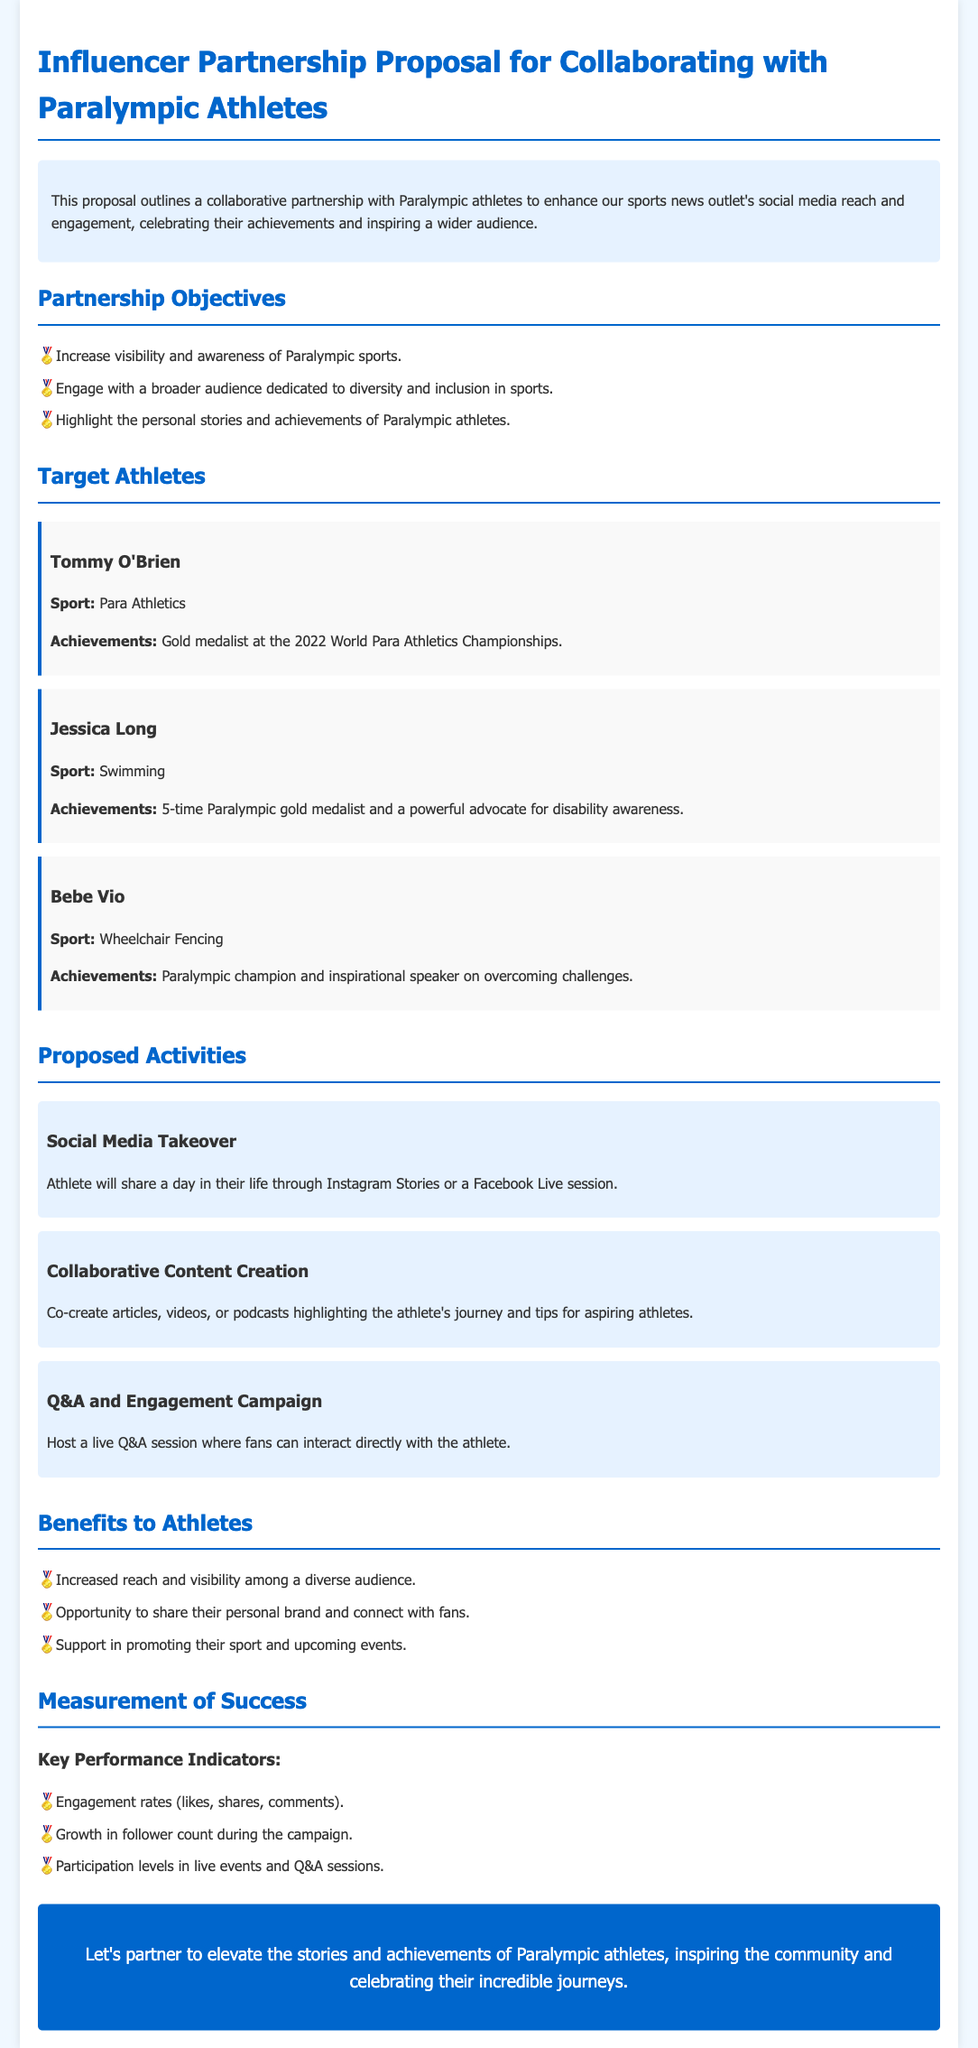What is the title of the proposal? The title clearly states the purpose of the document, which is "Influencer Partnership Proposal for Collaborating with Paralympic Athletes."
Answer: Influencer Partnership Proposal for Collaborating with Paralympic Athletes Who is a 5-time Paralympic gold medalist? The document mentions Jessica Long specifically as a 5-time Paralympic gold medalist.
Answer: Jessica Long What is one of the objectives of the partnership? The document lists several objectives, one of which includes increasing visibility and awareness of Paralympic sports.
Answer: Increase visibility and awareness of Paralympic sports How many proposed activities are listed? The document outlines three specific proposed activities for the partnership.
Answer: 3 What sport does Tommy O'Brien compete in? The document states that Tommy O'Brien is a Para Athletics competitor.
Answer: Para Athletics What type of engagement does the document suggest with the athletes? The proposal encourages hosting a live Q&A session where fans can interact directly with the athletes.
Answer: Live Q&A session What is one benefit to athletes mentioned in the proposal? The document highlights that athletes will have increased reach and visibility among a diverse audience as a benefit.
Answer: Increased reach and visibility What are the key performance indicators? The document outlines specific metrics to measure success, detailing engagement rates, follower growth, and participation levels.
Answer: Engagement rates, follower growth, participation levels 